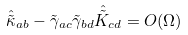Convert formula to latex. <formula><loc_0><loc_0><loc_500><loc_500>\hat { \tilde { \kappa } } _ { a b } - \tilde { \gamma } _ { a c } \tilde { \gamma } _ { b d } \hat { \tilde { K } } _ { c d } = O ( \Omega )</formula> 